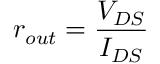<formula> <loc_0><loc_0><loc_500><loc_500>r _ { o u t } = { \frac { V _ { D S } } { I _ { D S } } }</formula> 